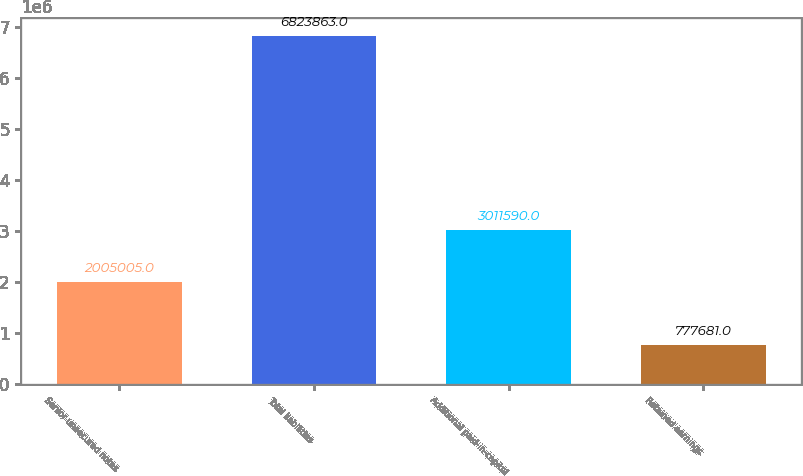Convert chart to OTSL. <chart><loc_0><loc_0><loc_500><loc_500><bar_chart><fcel>Senior unsecured notes<fcel>Total liabilities<fcel>Additional paid-in-capital<fcel>Retained earnings<nl><fcel>2.005e+06<fcel>6.82386e+06<fcel>3.01159e+06<fcel>777681<nl></chart> 